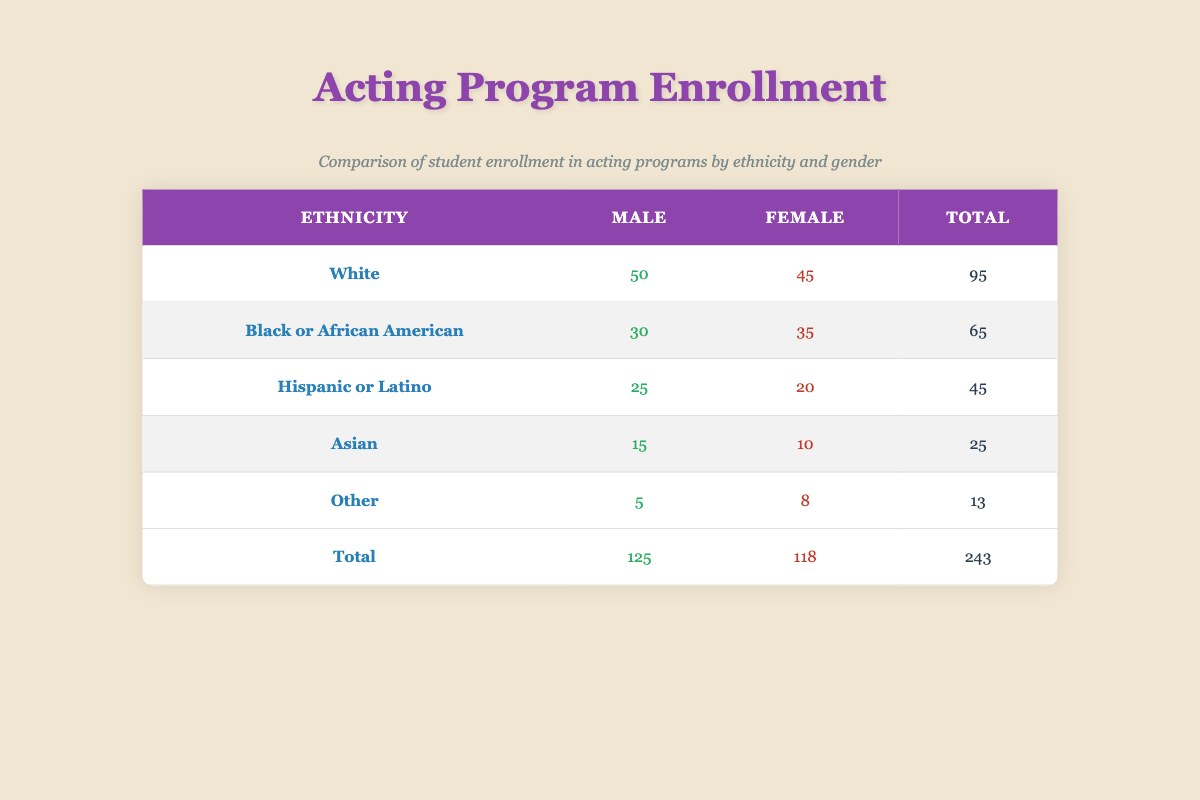What is the total enrollment for White students? According to the table, the enrollment count for White Male students is 50 and for White Female students is 45. Summing these gives 50 + 45 = 95.
Answer: 95 Which ethnicity has the highest total enrollment? By looking at the totals for each ethnicity in the table, White has 95, Black or African American has 65, Hispanic or Latino has 45, Asian has 25, and Other has 13. White has the highest total of 95.
Answer: White How many more Male students are enrolled compared to Female students? The total enrollment for Male students across all ethnicities is 125 (50+30+25+15+5) and for Female students, it is 118 (45+35+20+10+8). Calculating the difference, we find 125 - 118 = 7.
Answer: 7 Is the enrollment for Hispanic or Latino Female students greater than that for Asian Female students? The enrollment count for Hispanic or Latino Female students is 20, while for Asian Female students, it is 10. Since 20 is greater than 10, the statement is true.
Answer: Yes What percentage of the total enrollment is made up by Black or African American students? The total enrollment of Black or African American students is 65. The overall total enrollment is 243. To find the percentage, we calculate (65/243) * 100, which is approximately 26.8%.
Answer: 26.8% Which gender has a higher enrollment in the 'Other' ethnicity category? For the 'Other' ethnicity, Male enrollment is 5 and Female enrollment is 8. Comparing these two values, 8 (Female) is greater than 5 (Male).
Answer: Female What is the combined enrollment of Hispanic or Latino and Asian Male students? The enrollment count for Hispanic or Latino Male students is 25 and for Asian Male students it is 15. Adding these gives us 25 + 15 = 40.
Answer: 40 How many total students are enrolled in the Asian category? The total enrollment for the Asian category is the sum of Male and Female students: 15 (Male) + 10 (Female) = 25.
Answer: 25 